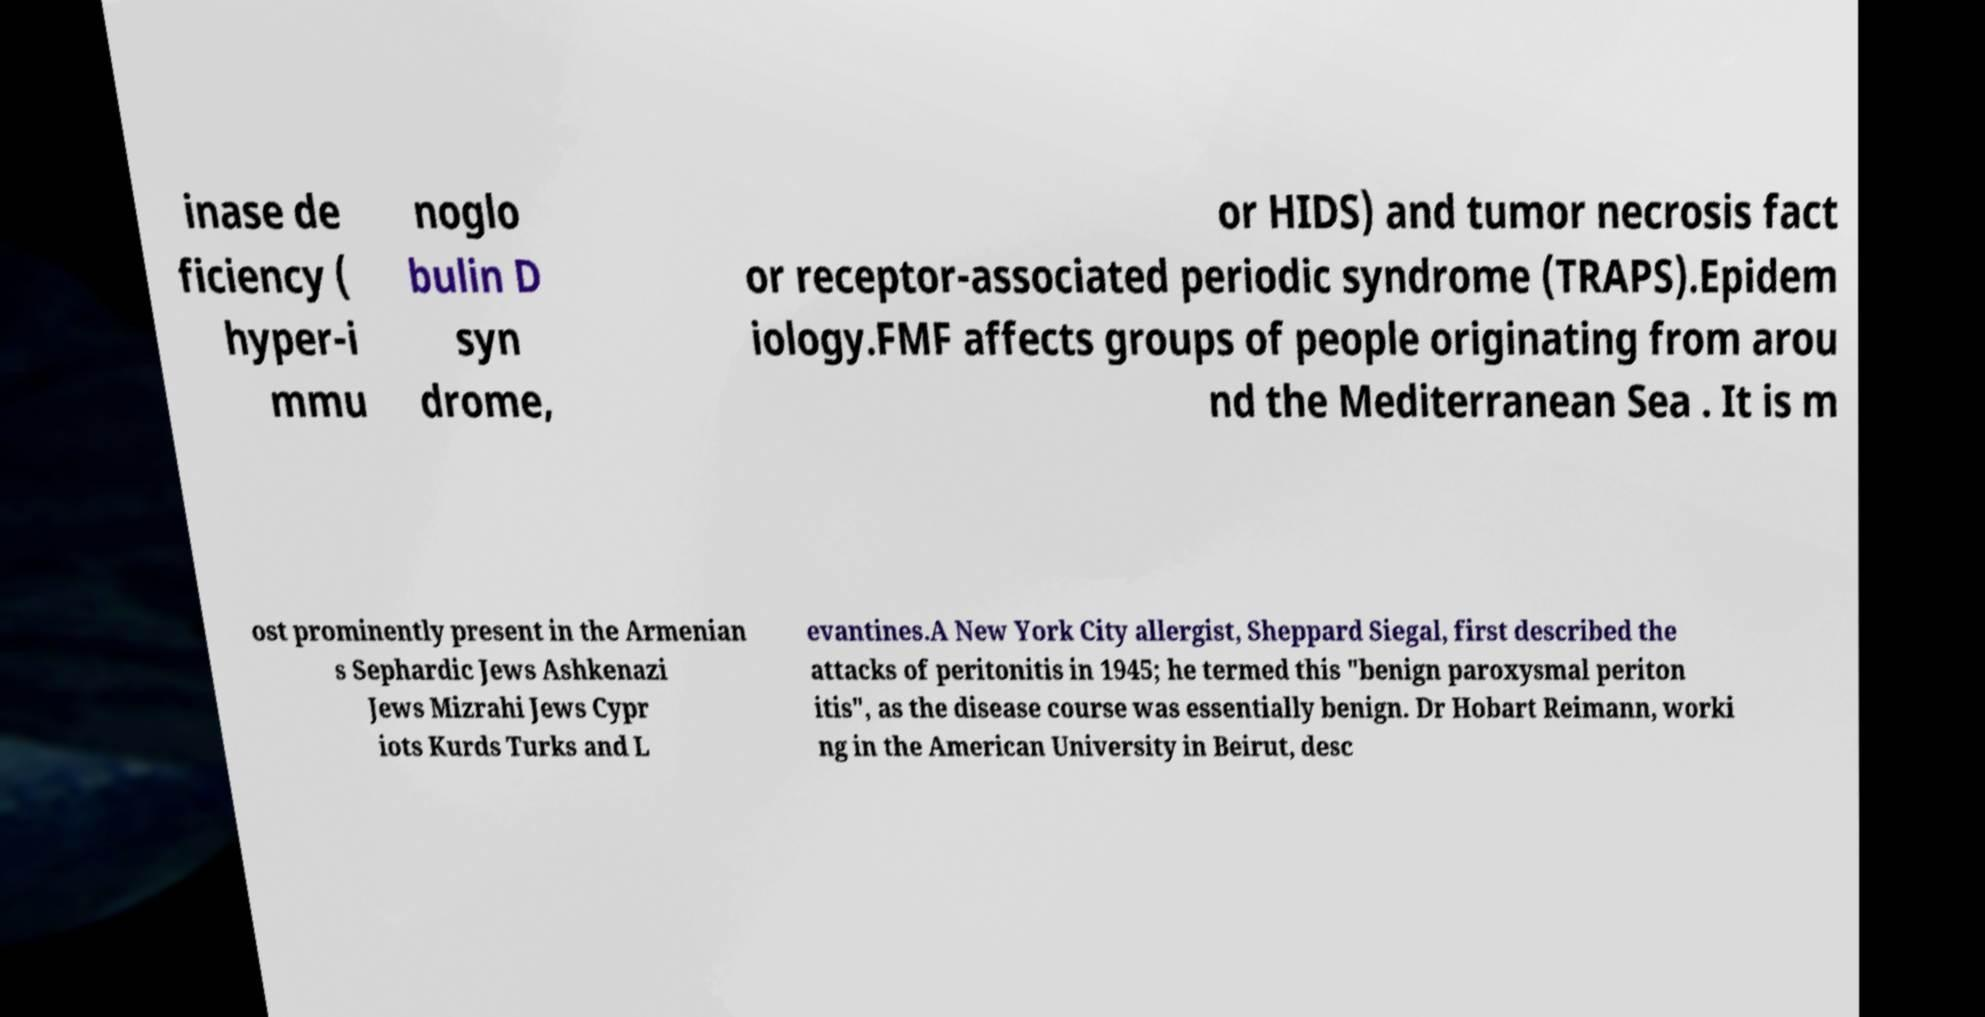Can you read and provide the text displayed in the image?This photo seems to have some interesting text. Can you extract and type it out for me? inase de ficiency ( hyper-i mmu noglo bulin D syn drome, or HIDS) and tumor necrosis fact or receptor-associated periodic syndrome (TRAPS).Epidem iology.FMF affects groups of people originating from arou nd the Mediterranean Sea . It is m ost prominently present in the Armenian s Sephardic Jews Ashkenazi Jews Mizrahi Jews Cypr iots Kurds Turks and L evantines.A New York City allergist, Sheppard Siegal, first described the attacks of peritonitis in 1945; he termed this "benign paroxysmal periton itis", as the disease course was essentially benign. Dr Hobart Reimann, worki ng in the American University in Beirut, desc 